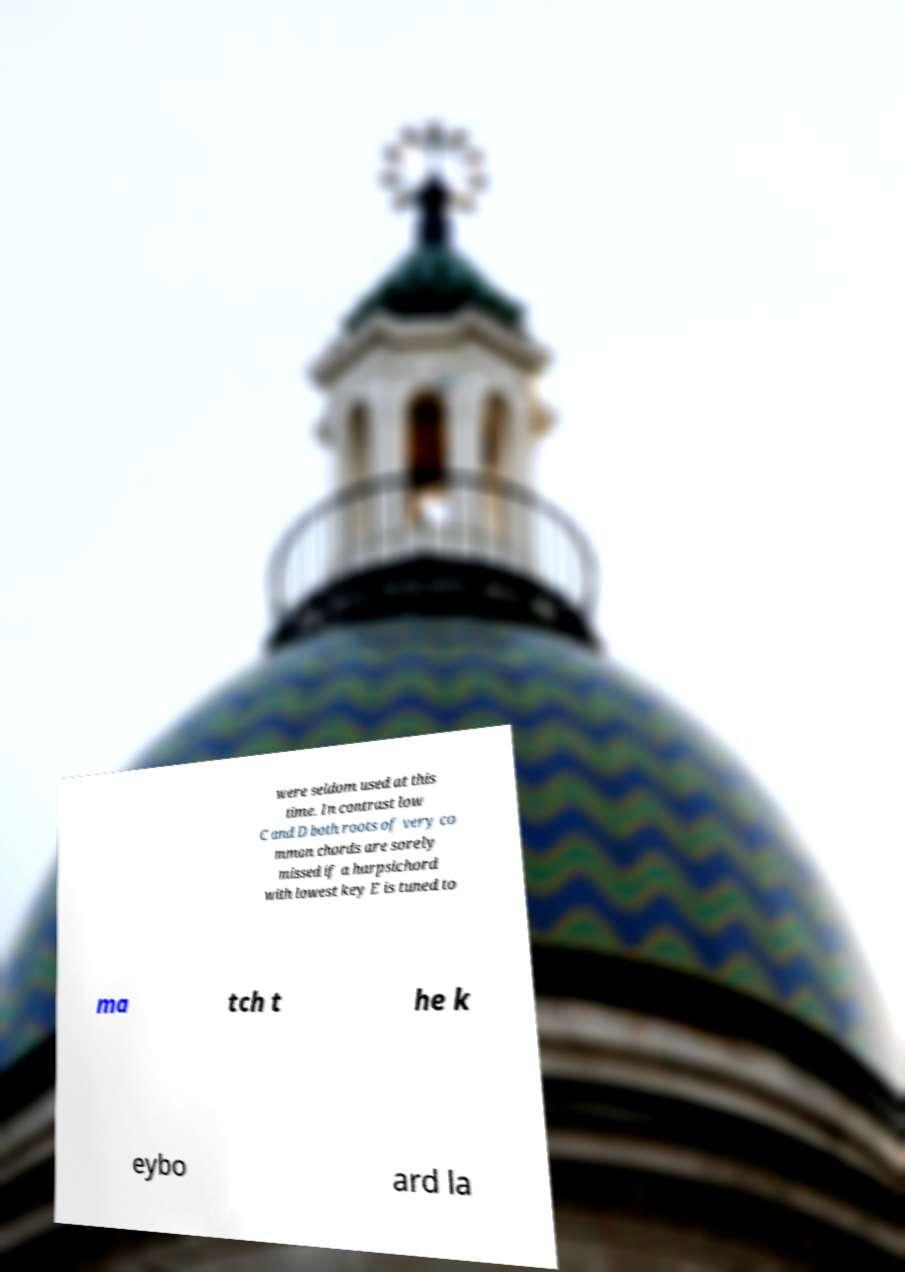Could you assist in decoding the text presented in this image and type it out clearly? were seldom used at this time. In contrast low C and D both roots of very co mmon chords are sorely missed if a harpsichord with lowest key E is tuned to ma tch t he k eybo ard la 